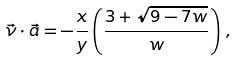<formula> <loc_0><loc_0><loc_500><loc_500>\vec { \nu } \cdot \vec { a } = - \frac { x } { y } \left ( \frac { 3 + \sqrt { 9 - 7 w } } w \right ) \, ,</formula> 